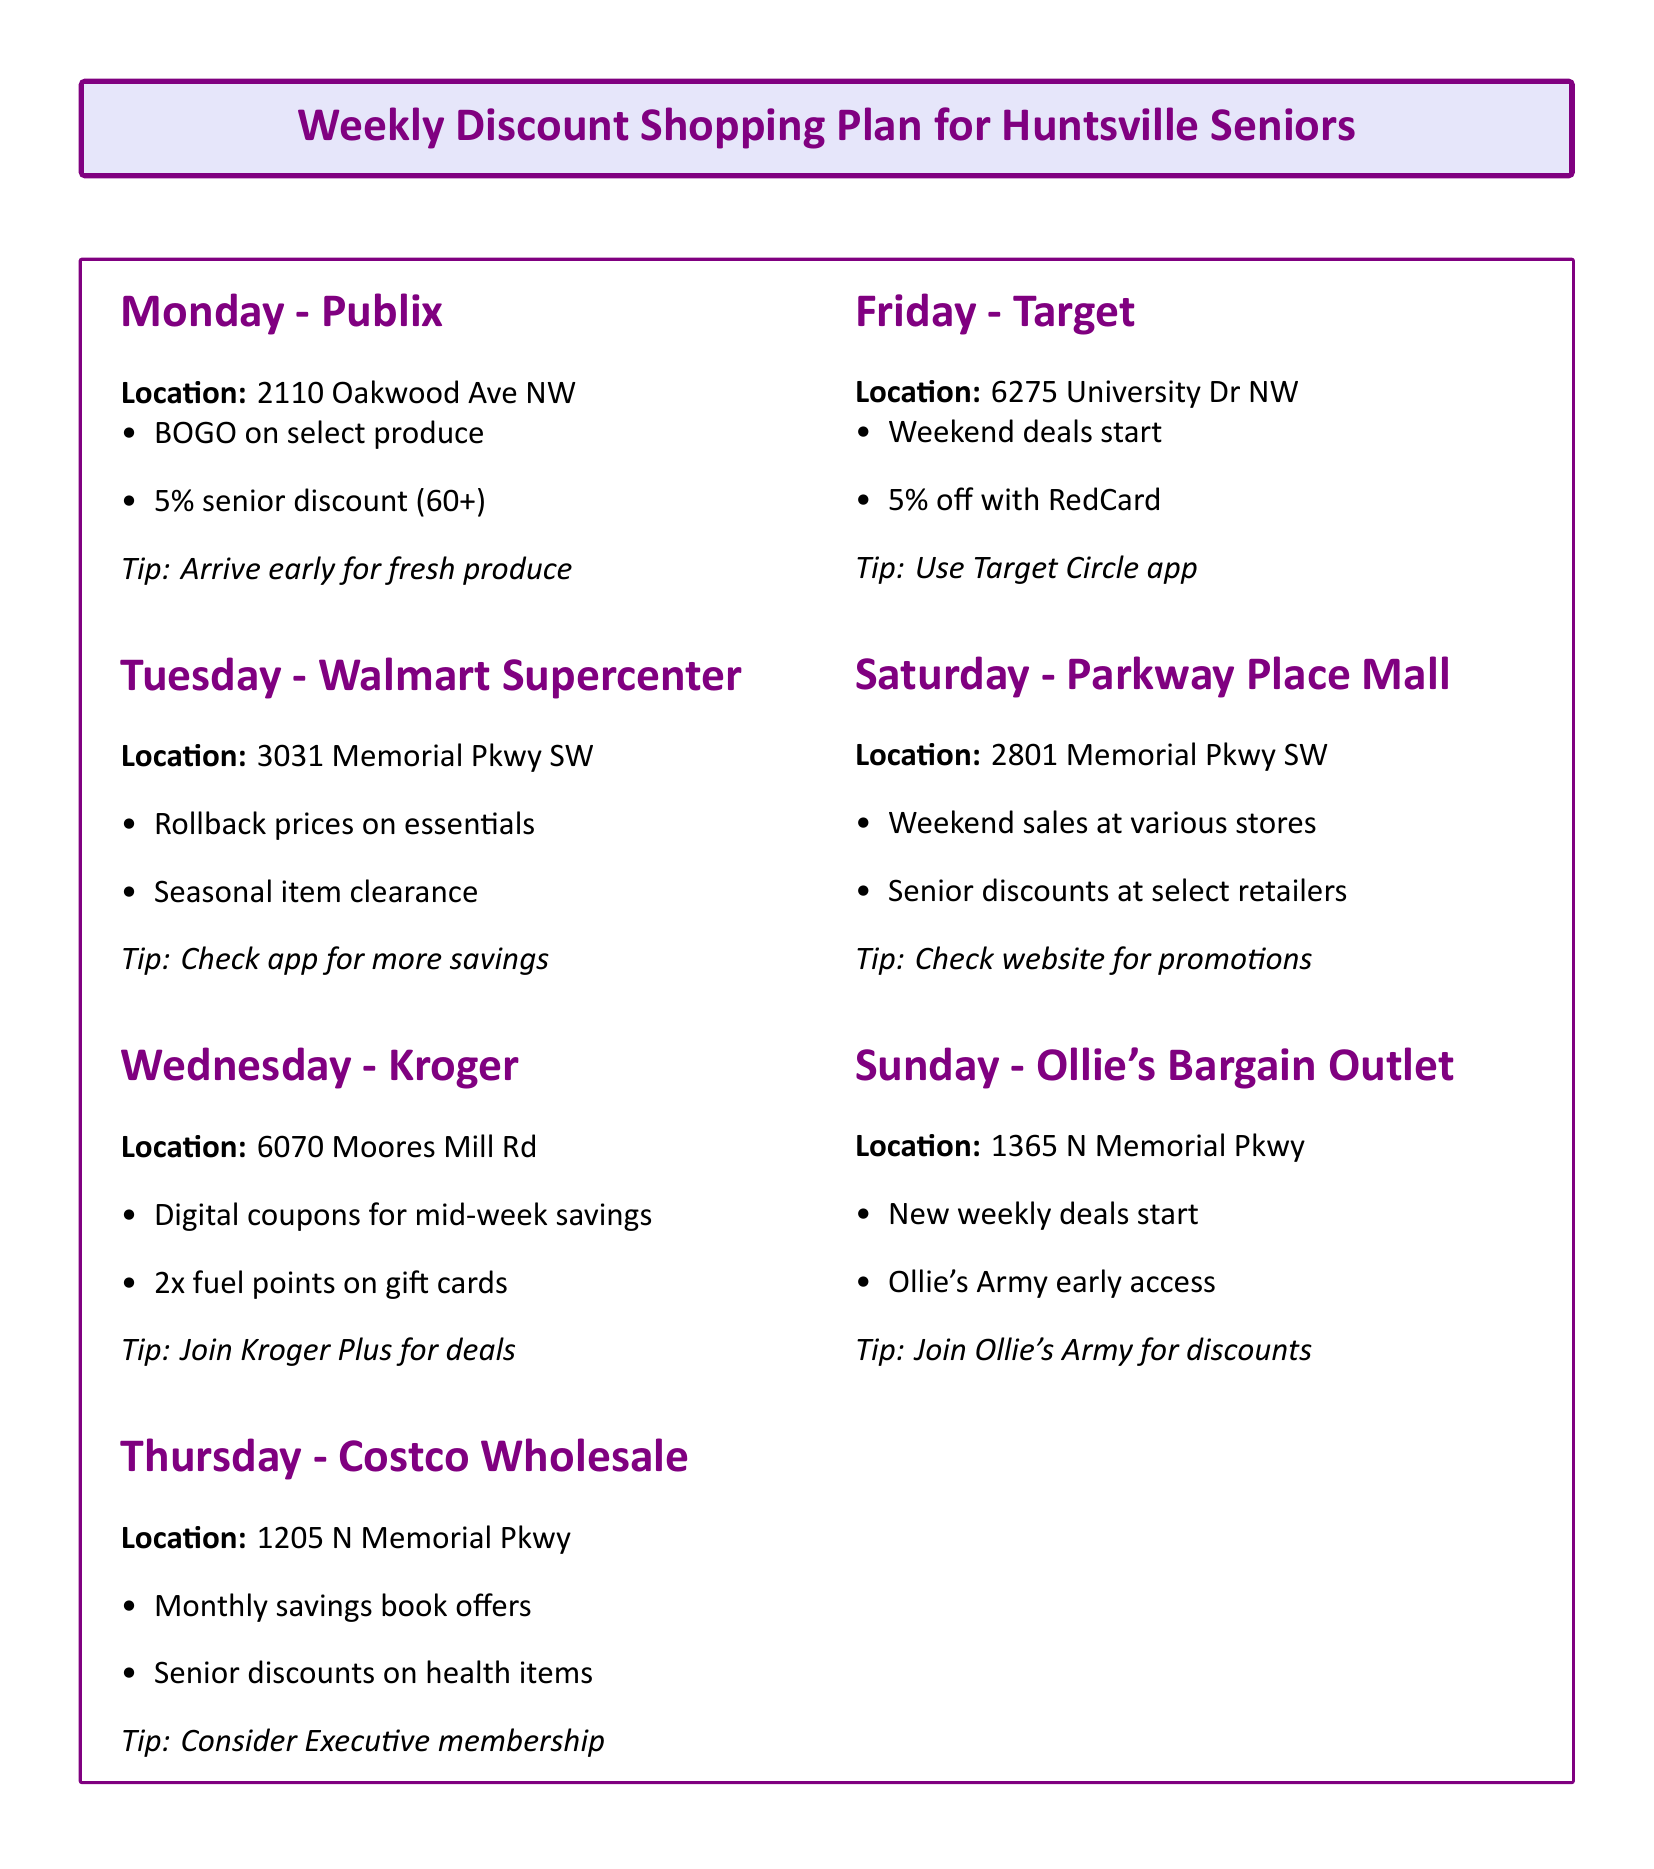What is the best day to shop at Publix? The best day to shop at Publix, as mentioned in the document, is Monday.
Answer: Monday Where is the Walmart Supercenter located? The document provides the specific address for the Walmart Supercenter, which is 3031 Memorial Pkwy SW, Huntsville, AL 35801.
Answer: 3031 Memorial Pkwy SW, Huntsville, AL 35801 What discount is offered on senior purchases at Costco? The document states that there is a discount on hearing aids and eyeglasses for seniors at Costco.
Answer: Discount on hearing aids and eyeglasses for seniors Which store has a fuel points promotion? The document indicates that Kroger has a fuel points promotion for earning 2x points on gift card purchases.
Answer: Kroger What percentage off do seniors get at Publix? The document specifies a 5% discount for seniors (60+) at Publix.
Answer: 5% Which app should you use for exclusive offers at Target? The document mentions that the Target Circle app is recommended for exclusive offers and cashback.
Answer: Target Circle app What is the location of Ollie's Bargain Outlet? The document provides the location of Ollie's Bargain Outlet as 1365 N Memorial Pkwy, Huntsville, AL 35801.
Answer: 1365 N Memorial Pkwy, Huntsville, AL 35801 What additional savings can I find at Walmart? The document advises checking the Walmart app for additional savings on Tuesday.
Answer: Check the Walmart app What special offer is available for seniors at Parkway Place Mall? The document states there are senior discounts at select stores like Belk and JCPenney at Parkway Place Mall.
Answer: Senior discounts at select stores like Belk and JCPenney 